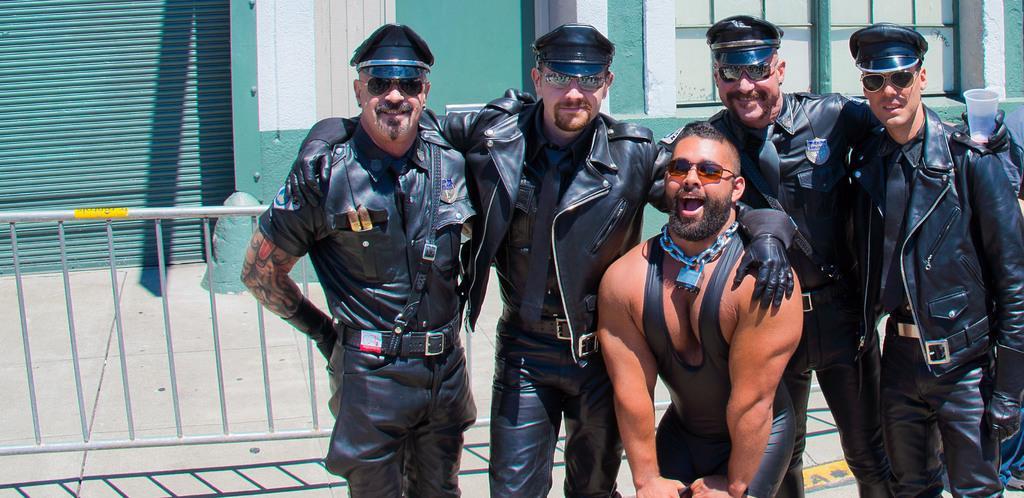Please provide a concise description of this image. In this image we can see five persons wearing goggles in which one of them is wearing a chain around his neck with a lock and the others are in the uniform and wearing caps, behind them we can see a fence, a building, a shutter and windows. 